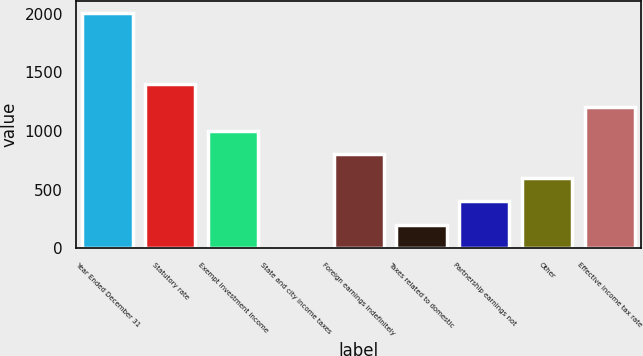Convert chart to OTSL. <chart><loc_0><loc_0><loc_500><loc_500><bar_chart><fcel>Year Ended December 31<fcel>Statutory rate<fcel>Exempt investment income<fcel>State and city income taxes<fcel>Foreign earnings indefinitely<fcel>Taxes related to domestic<fcel>Partnership earnings not<fcel>Other<fcel>Effective income tax rate<nl><fcel>2006<fcel>1404.5<fcel>1003.5<fcel>1<fcel>803<fcel>201.5<fcel>402<fcel>602.5<fcel>1204<nl></chart> 